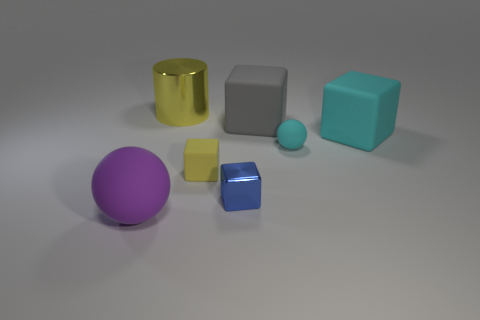Subtract 1 cubes. How many cubes are left? 3 Add 1 small cyan cylinders. How many objects exist? 8 Subtract all cylinders. How many objects are left? 6 Add 2 big yellow cylinders. How many big yellow cylinders are left? 3 Add 6 blue metal things. How many blue metal things exist? 7 Subtract 0 brown blocks. How many objects are left? 7 Subtract all gray blocks. Subtract all tiny cyan rubber things. How many objects are left? 5 